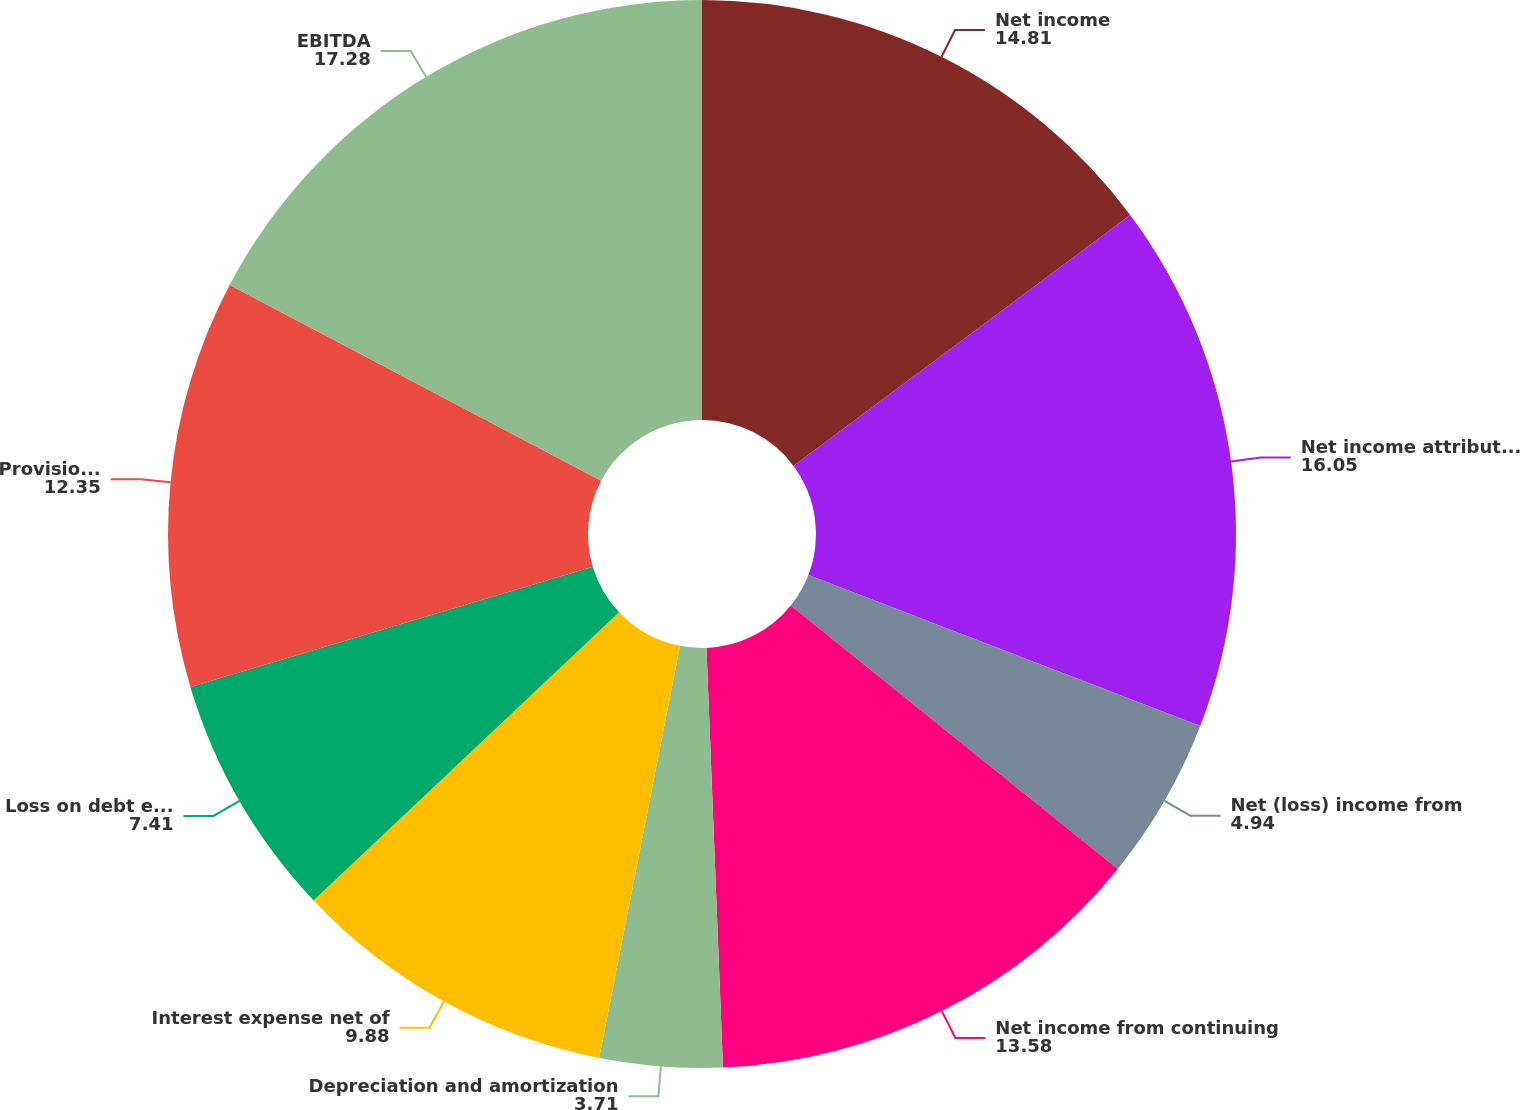<chart> <loc_0><loc_0><loc_500><loc_500><pie_chart><fcel>Net income<fcel>Net income attributable to LKQ<fcel>Net (loss) income from<fcel>Net income from continuing<fcel>Depreciation and amortization<fcel>Interest expense net of<fcel>Loss on debt extinguishment<fcel>Provision for income taxes<fcel>EBITDA<nl><fcel>14.81%<fcel>16.05%<fcel>4.94%<fcel>13.58%<fcel>3.71%<fcel>9.88%<fcel>7.41%<fcel>12.35%<fcel>17.28%<nl></chart> 